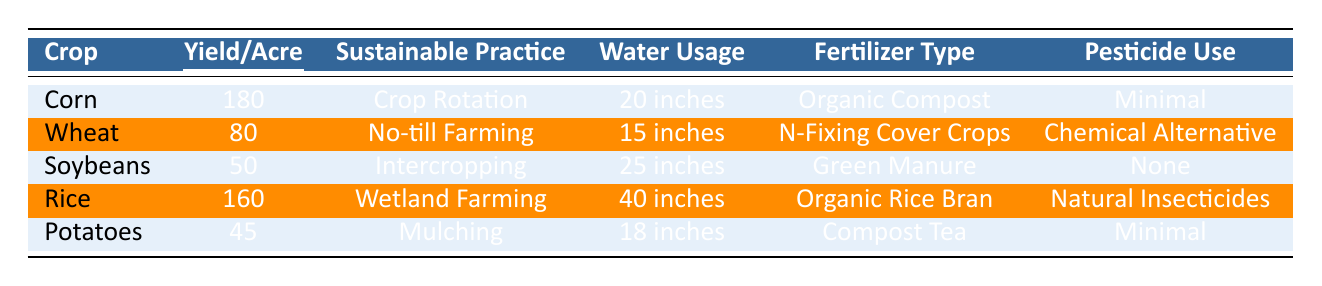What is the highest yield per acre among the crops listed? By reviewing the "Yield_per_Acre" column in the table, we find that Corn has the highest yield value of 180, making it the highest yield per acre.
Answer: 180 Which sustainable practice is used for Soybeans? Looking at the "Sustainable Practice" column corresponding to Soybeans, it states that the practice used is Intercropping.
Answer: Intercropping How much water do Wheat crops require? Referring to the "Water Usage" column for Wheat, it clearly shows that it requires 15 inches of water.
Answer: 15 inches What is the average yield per acre of Rice and Corn combined? First, we find the yield for Rice (160) and Corn (180). We then add them together: 160 + 180 = 340. Finally, we divide by 2 (the number of crops): 340 / 2 = 170.
Answer: 170 Are there any crops that use no pesticides? By examining the "Pesticide Use" column, we see that Soybeans state "None" for pesticide use, indicating that it does not use any pesticides.
Answer: Yes Which crop requires the most water, and how much is it? By evaluating the "Water Usage" values, we observe that the Rice crop requires 40 inches, which is the highest among all listed crops.
Answer: Rice, 40 inches If we compare the yield of Potatoes and Soybeans, which is higher and by how much? The yield for Potatoes is 45 and for Soybeans it is 50. The difference is calculated by subtracting: 50 - 45 = 5, indicating Soybeans have a higher yield by 5.
Answer: Soybeans, 5 What type of fertilizer is used for Corn? From the "Fertilizer Type" column for Corn, it indicates the use of Organic Compost.
Answer: Organic Compost Which crop has the lowest yield and what is that yield? Looking closely at the "Yield_per_Acre" column, we find that Potatoes have the lowest yield, which is 45.
Answer: 45 Is Natural Insecticide used for any crop on the list? Upon checking the "Pesticide Use" column, we see that Rice is the only crop that uses Natural Insecticides.
Answer: Yes 